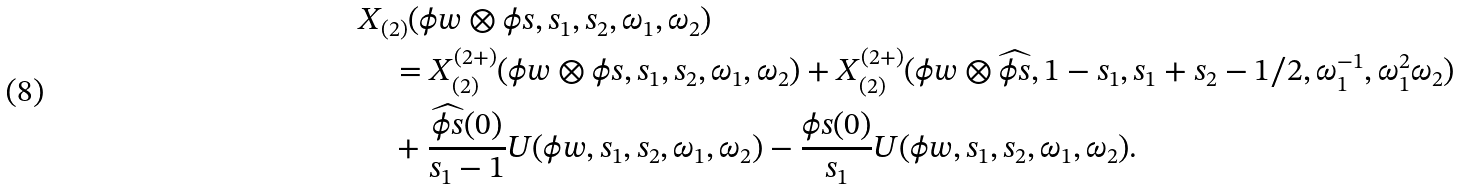<formula> <loc_0><loc_0><loc_500><loc_500>& X _ { ( 2 ) } ( \phi w \otimes \phi s , s _ { 1 } , s _ { 2 } , \omega _ { 1 } , \omega _ { 2 } ) \\ & \quad = X _ { ( 2 ) } ^ { ( 2 + ) } ( \phi w \otimes \phi s , s _ { 1 } , s _ { 2 } , \omega _ { 1 } , \omega _ { 2 } ) + X _ { ( 2 ) } ^ { ( 2 + ) } ( \phi w \otimes \widehat { \phi s } , 1 - s _ { 1 } , s _ { 1 } + s _ { 2 } - 1 / 2 , \omega _ { 1 } ^ { - 1 } , \omega _ { 1 } ^ { 2 } \omega _ { 2 } ) \\ & \quad + \frac { \widehat { \phi s } ( 0 ) } { s _ { 1 } - 1 } U ( \phi w , s _ { 1 } , s _ { 2 } , \omega _ { 1 } , \omega _ { 2 } ) - \frac { \phi s ( 0 ) } { s _ { 1 } } U ( \phi w , s _ { 1 } , s _ { 2 } , \omega _ { 1 } , \omega _ { 2 } ) .</formula> 